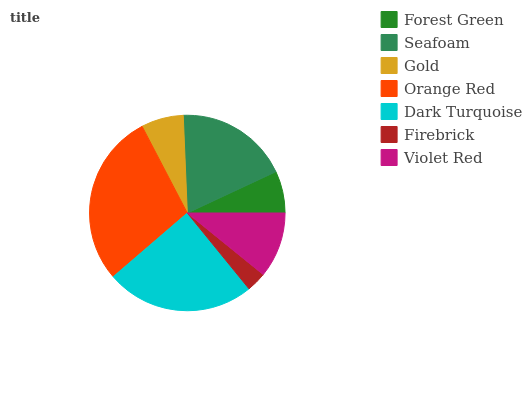Is Firebrick the minimum?
Answer yes or no. Yes. Is Orange Red the maximum?
Answer yes or no. Yes. Is Seafoam the minimum?
Answer yes or no. No. Is Seafoam the maximum?
Answer yes or no. No. Is Seafoam greater than Forest Green?
Answer yes or no. Yes. Is Forest Green less than Seafoam?
Answer yes or no. Yes. Is Forest Green greater than Seafoam?
Answer yes or no. No. Is Seafoam less than Forest Green?
Answer yes or no. No. Is Violet Red the high median?
Answer yes or no. Yes. Is Violet Red the low median?
Answer yes or no. Yes. Is Gold the high median?
Answer yes or no. No. Is Orange Red the low median?
Answer yes or no. No. 